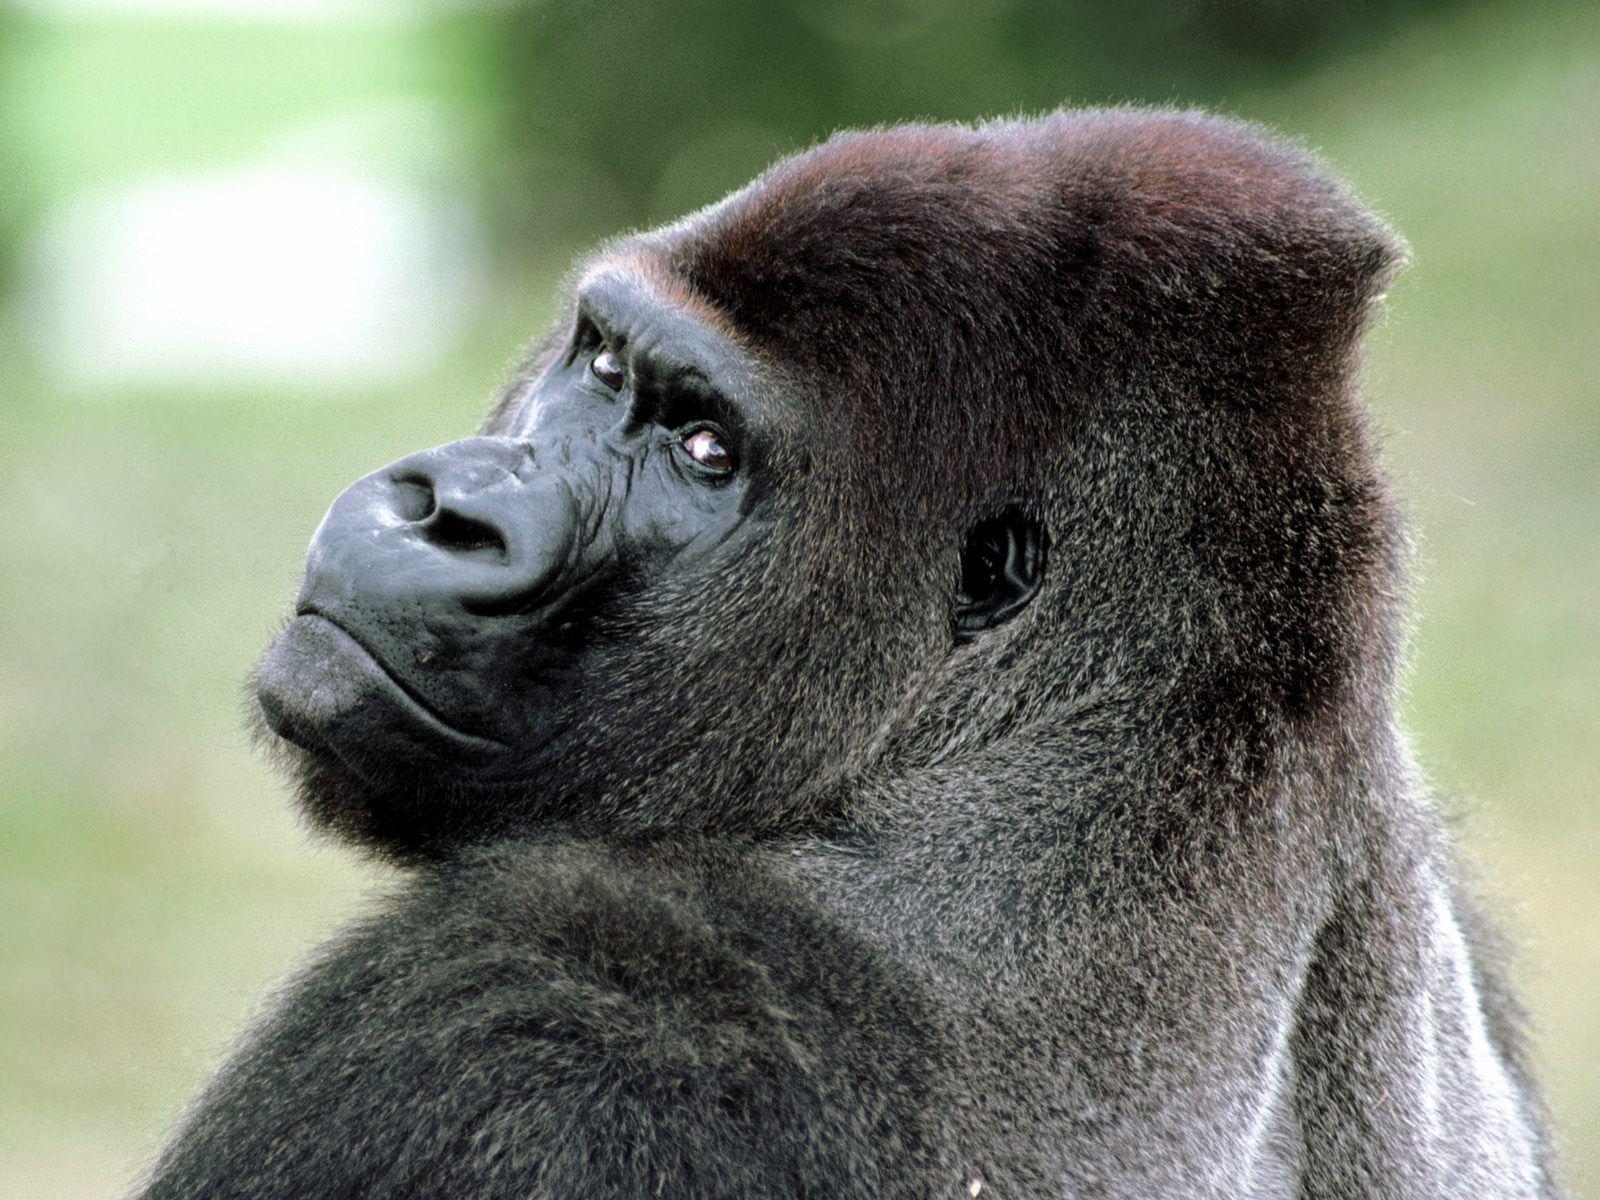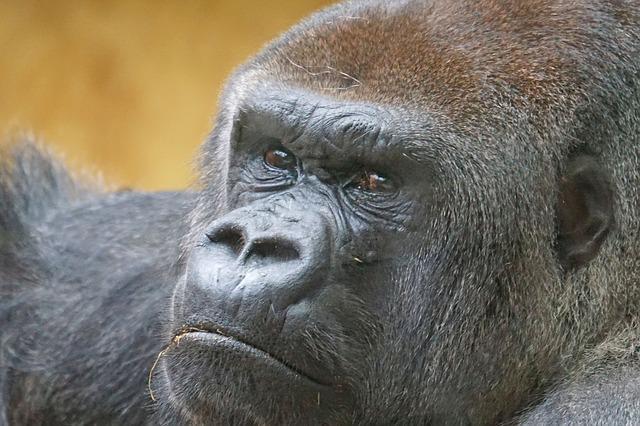The first image is the image on the left, the second image is the image on the right. For the images shown, is this caption "One image includes a silverback gorilla on all fours, and the other shows a silverback gorilla sitting on green grass." true? Answer yes or no. No. The first image is the image on the left, the second image is the image on the right. Considering the images on both sides, is "The gorilla in the right image is sitting in the grass near a bunch of weeds." valid? Answer yes or no. No. 